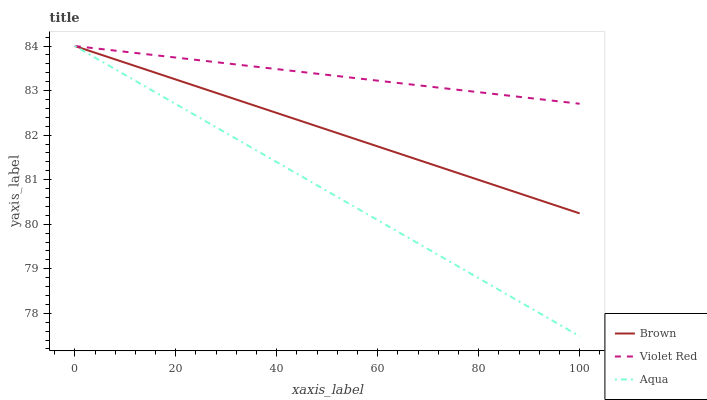Does Aqua have the minimum area under the curve?
Answer yes or no. Yes. Does Violet Red have the maximum area under the curve?
Answer yes or no. Yes. Does Violet Red have the minimum area under the curve?
Answer yes or no. No. Does Aqua have the maximum area under the curve?
Answer yes or no. No. Is Aqua the smoothest?
Answer yes or no. Yes. Is Brown the roughest?
Answer yes or no. Yes. Is Violet Red the smoothest?
Answer yes or no. No. Is Violet Red the roughest?
Answer yes or no. No. Does Violet Red have the lowest value?
Answer yes or no. No. Does Aqua have the highest value?
Answer yes or no. Yes. Does Violet Red intersect Brown?
Answer yes or no. Yes. Is Violet Red less than Brown?
Answer yes or no. No. Is Violet Red greater than Brown?
Answer yes or no. No. 